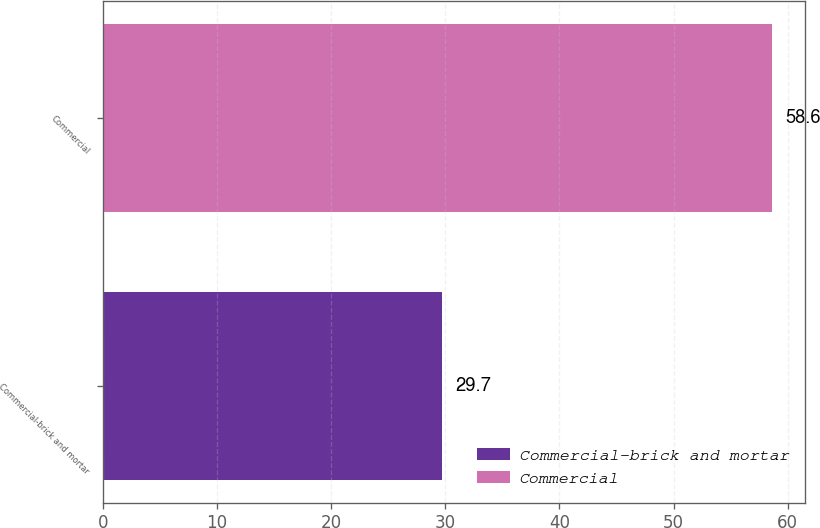<chart> <loc_0><loc_0><loc_500><loc_500><bar_chart><fcel>Commercial-brick and mortar<fcel>Commercial<nl><fcel>29.7<fcel>58.6<nl></chart> 